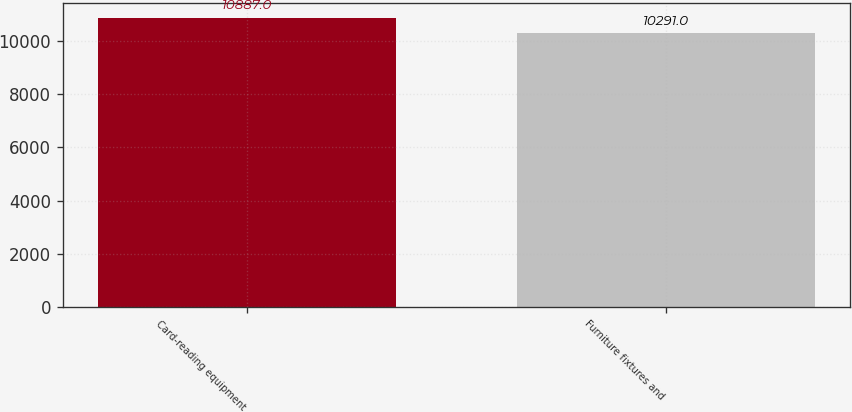<chart> <loc_0><loc_0><loc_500><loc_500><bar_chart><fcel>Card-reading equipment<fcel>Furniture fixtures and<nl><fcel>10887<fcel>10291<nl></chart> 